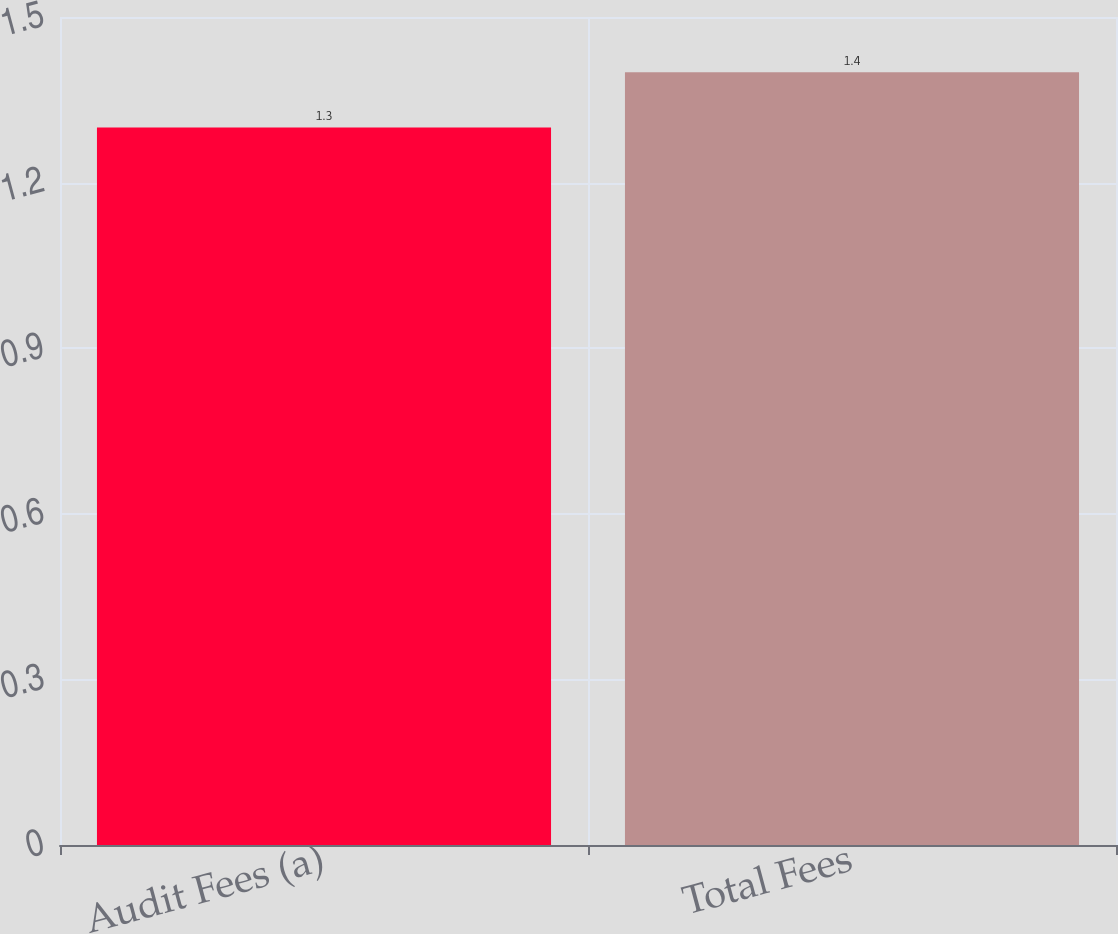Convert chart. <chart><loc_0><loc_0><loc_500><loc_500><bar_chart><fcel>Audit Fees (a)<fcel>Total Fees<nl><fcel>1.3<fcel>1.4<nl></chart> 